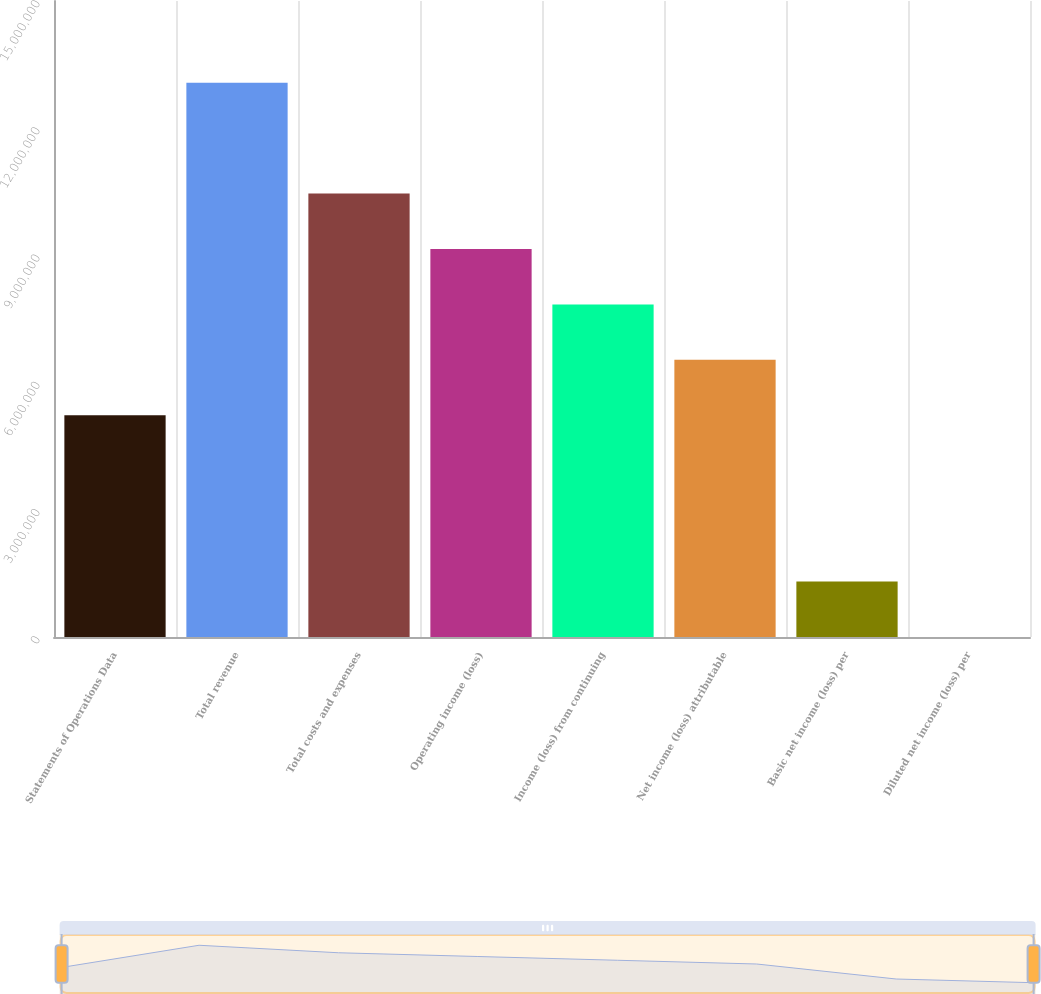<chart> <loc_0><loc_0><loc_500><loc_500><bar_chart><fcel>Statements of Operations Data<fcel>Total revenue<fcel>Total costs and expenses<fcel>Operating income (loss)<fcel>Income (loss) from continuing<fcel>Net income (loss) attributable<fcel>Basic net income (loss) per<fcel>Diluted net income (loss) per<nl><fcel>5.22963e+06<fcel>1.30741e+07<fcel>1.04593e+07<fcel>9.15185e+06<fcel>7.84444e+06<fcel>6.53703e+06<fcel>1.30741e+06<fcel>3.39<nl></chart> 